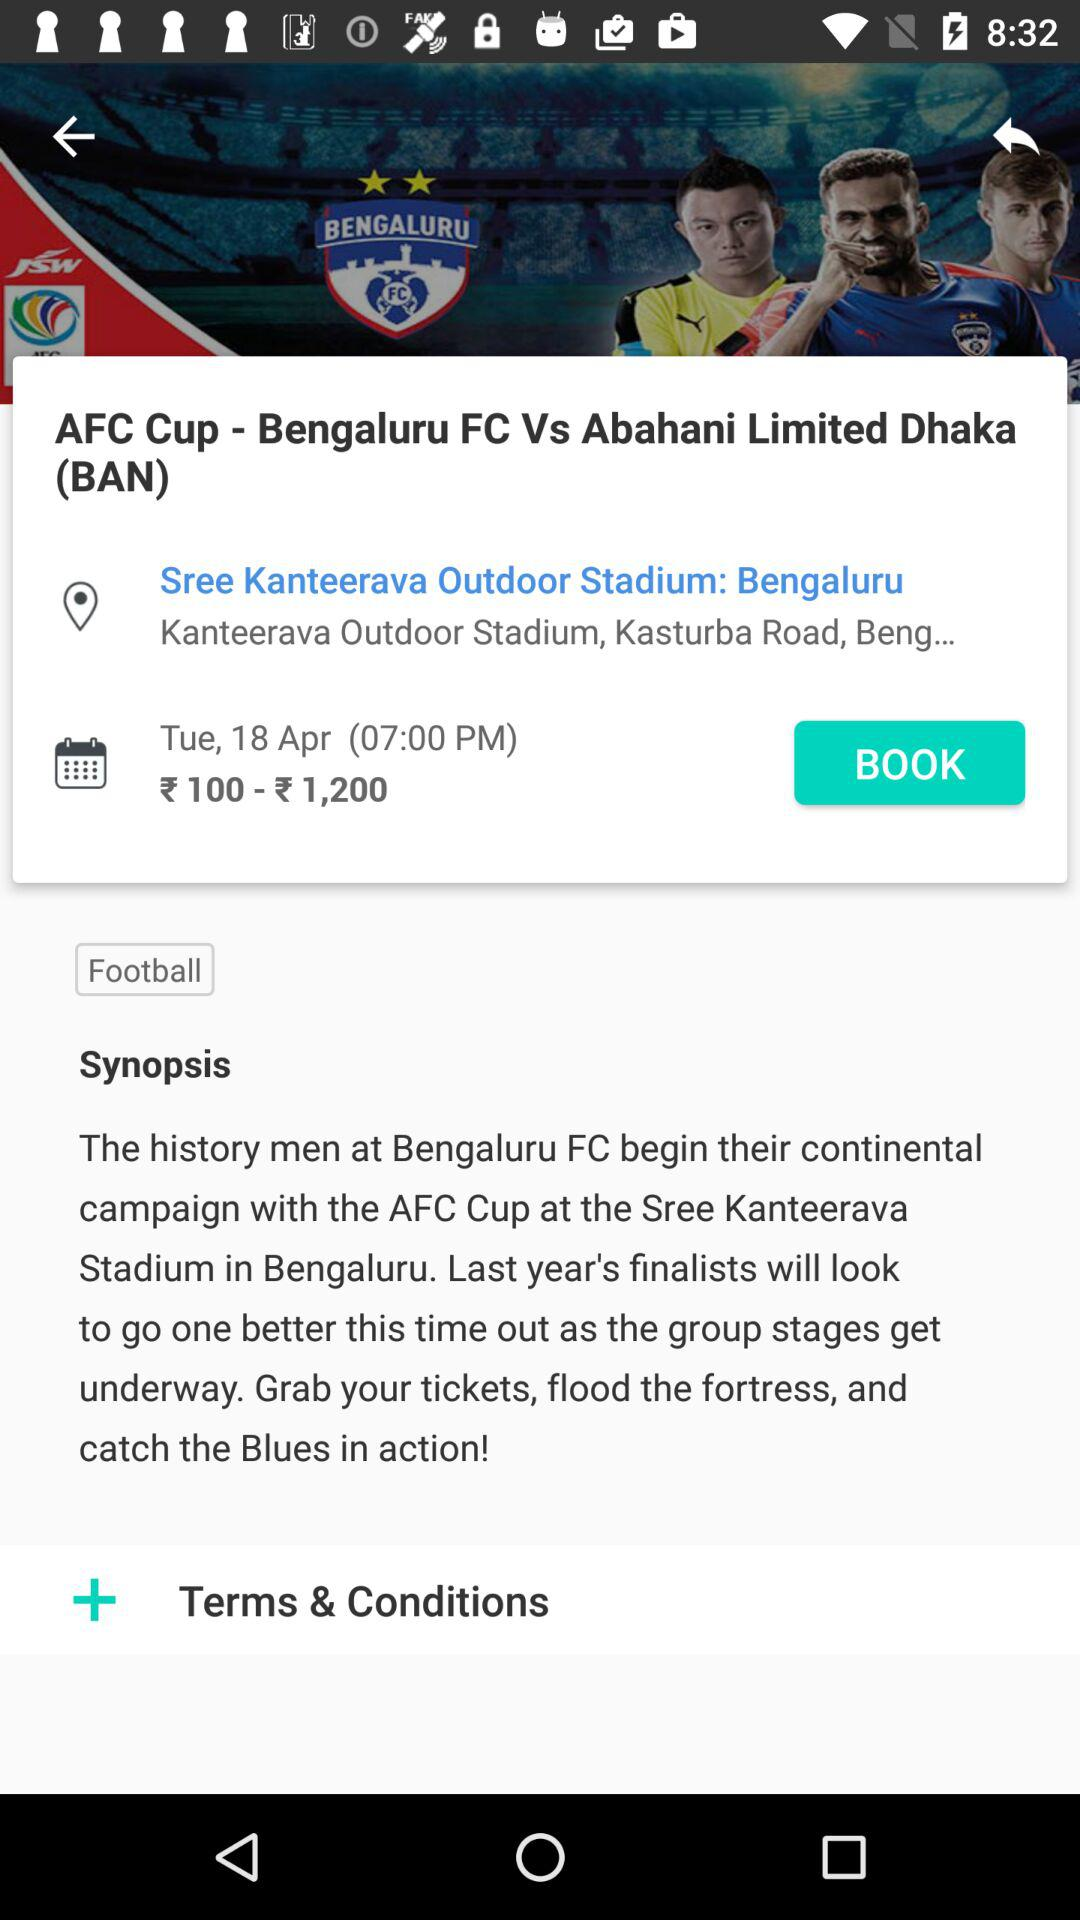What is the price of the ticket? The ticket price ranges from ₹ 100 to ₹ 1,200. 